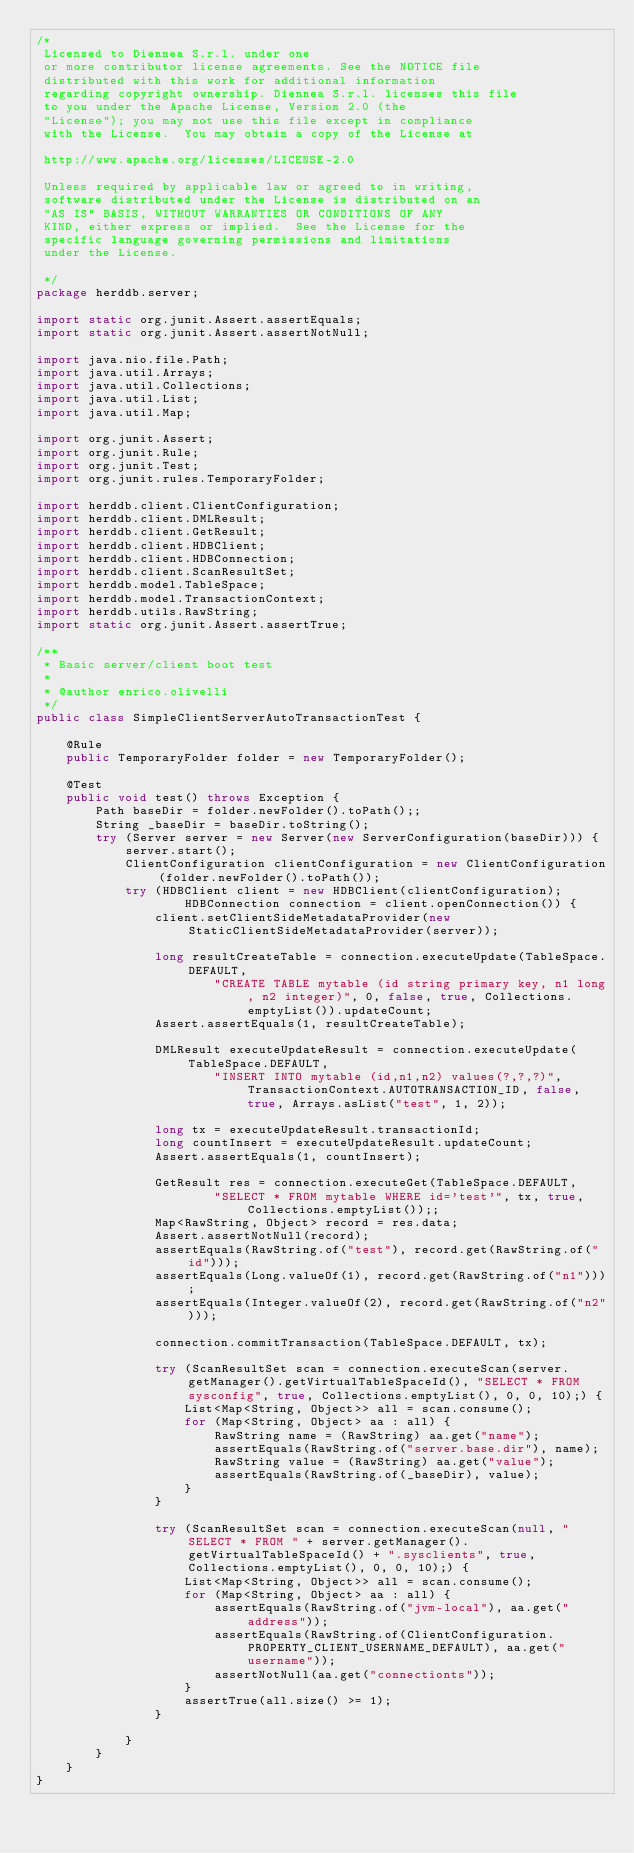Convert code to text. <code><loc_0><loc_0><loc_500><loc_500><_Java_>/*
 Licensed to Diennea S.r.l. under one
 or more contributor license agreements. See the NOTICE file
 distributed with this work for additional information
 regarding copyright ownership. Diennea S.r.l. licenses this file
 to you under the Apache License, Version 2.0 (the
 "License"); you may not use this file except in compliance
 with the License.  You may obtain a copy of the License at

 http://www.apache.org/licenses/LICENSE-2.0

 Unless required by applicable law or agreed to in writing,
 software distributed under the License is distributed on an
 "AS IS" BASIS, WITHOUT WARRANTIES OR CONDITIONS OF ANY
 KIND, either express or implied.  See the License for the
 specific language governing permissions and limitations
 under the License.

 */
package herddb.server;

import static org.junit.Assert.assertEquals;
import static org.junit.Assert.assertNotNull;

import java.nio.file.Path;
import java.util.Arrays;
import java.util.Collections;
import java.util.List;
import java.util.Map;

import org.junit.Assert;
import org.junit.Rule;
import org.junit.Test;
import org.junit.rules.TemporaryFolder;

import herddb.client.ClientConfiguration;
import herddb.client.DMLResult;
import herddb.client.GetResult;
import herddb.client.HDBClient;
import herddb.client.HDBConnection;
import herddb.client.ScanResultSet;
import herddb.model.TableSpace;
import herddb.model.TransactionContext;
import herddb.utils.RawString;
import static org.junit.Assert.assertTrue;

/**
 * Basic server/client boot test
 *
 * @author enrico.olivelli
 */
public class SimpleClientServerAutoTransactionTest {

    @Rule
    public TemporaryFolder folder = new TemporaryFolder();

    @Test
    public void test() throws Exception {
        Path baseDir = folder.newFolder().toPath();;
        String _baseDir = baseDir.toString();
        try (Server server = new Server(new ServerConfiguration(baseDir))) {
            server.start();
            ClientConfiguration clientConfiguration = new ClientConfiguration(folder.newFolder().toPath());
            try (HDBClient client = new HDBClient(clientConfiguration);
                    HDBConnection connection = client.openConnection()) {
                client.setClientSideMetadataProvider(new StaticClientSideMetadataProvider(server));

                long resultCreateTable = connection.executeUpdate(TableSpace.DEFAULT,
                        "CREATE TABLE mytable (id string primary key, n1 long, n2 integer)", 0, false, true, Collections.emptyList()).updateCount;
                Assert.assertEquals(1, resultCreateTable);

                DMLResult executeUpdateResult = connection.executeUpdate(TableSpace.DEFAULT,
                        "INSERT INTO mytable (id,n1,n2) values(?,?,?)", TransactionContext.AUTOTRANSACTION_ID, false, true, Arrays.asList("test", 1, 2));

                long tx = executeUpdateResult.transactionId;
                long countInsert = executeUpdateResult.updateCount;
                Assert.assertEquals(1, countInsert);

                GetResult res = connection.executeGet(TableSpace.DEFAULT,
                        "SELECT * FROM mytable WHERE id='test'", tx, true, Collections.emptyList());;
                Map<RawString, Object> record = res.data;
                Assert.assertNotNull(record);
                assertEquals(RawString.of("test"), record.get(RawString.of("id")));
                assertEquals(Long.valueOf(1), record.get(RawString.of("n1")));
                assertEquals(Integer.valueOf(2), record.get(RawString.of("n2")));

                connection.commitTransaction(TableSpace.DEFAULT, tx);

                try (ScanResultSet scan = connection.executeScan(server.getManager().getVirtualTableSpaceId(), "SELECT * FROM sysconfig", true, Collections.emptyList(), 0, 0, 10);) {
                    List<Map<String, Object>> all = scan.consume();
                    for (Map<String, Object> aa : all) {
                        RawString name = (RawString) aa.get("name");
                        assertEquals(RawString.of("server.base.dir"), name);
                        RawString value = (RawString) aa.get("value");
                        assertEquals(RawString.of(_baseDir), value);
                    }
                }

                try (ScanResultSet scan = connection.executeScan(null, "SELECT * FROM " + server.getManager().getVirtualTableSpaceId() + ".sysclients", true, Collections.emptyList(), 0, 0, 10);) {
                    List<Map<String, Object>> all = scan.consume();
                    for (Map<String, Object> aa : all) {
                        assertEquals(RawString.of("jvm-local"), aa.get("address"));
                        assertEquals(RawString.of(ClientConfiguration.PROPERTY_CLIENT_USERNAME_DEFAULT), aa.get("username"));
                        assertNotNull(aa.get("connectionts"));
                    }
                    assertTrue(all.size() >= 1);
                }

            }
        }
    }
}
</code> 